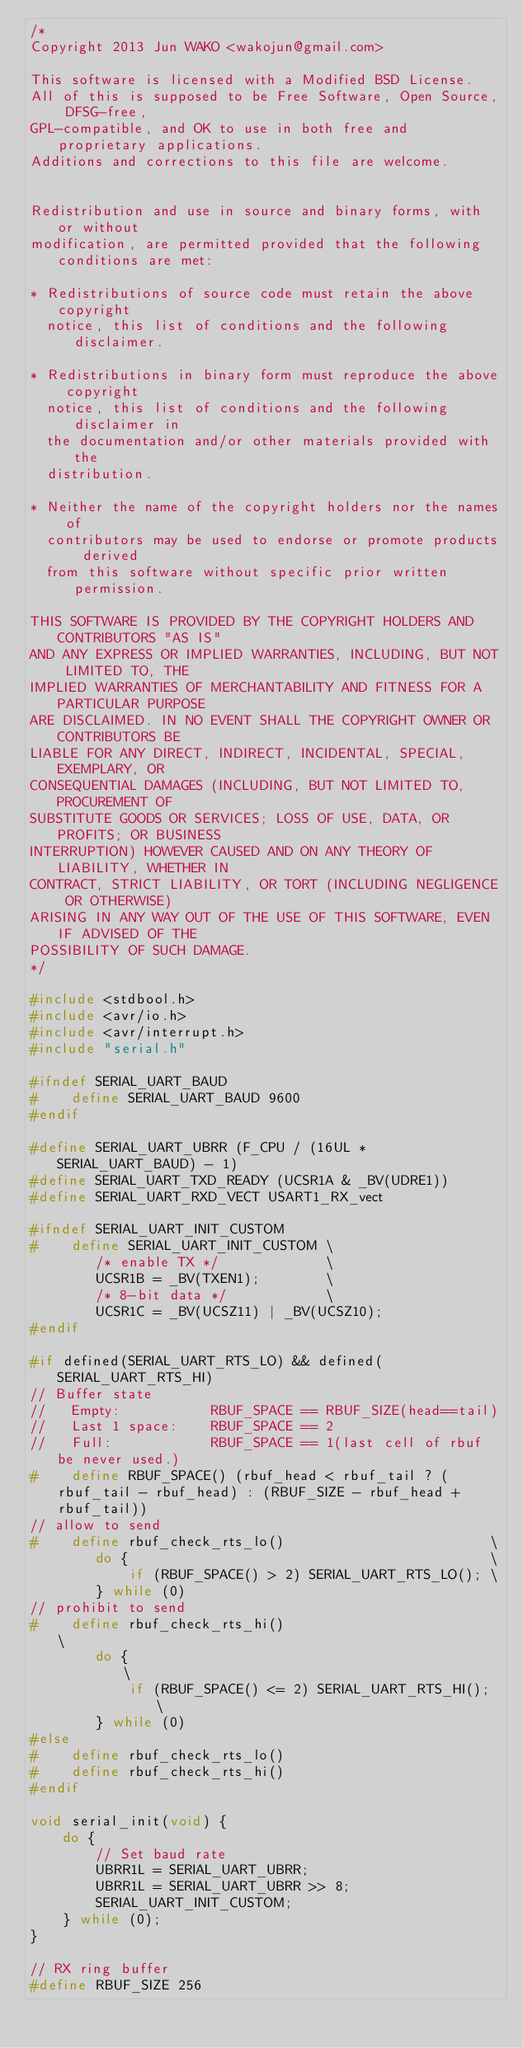<code> <loc_0><loc_0><loc_500><loc_500><_C_>/*
Copyright 2013 Jun WAKO <wakojun@gmail.com>

This software is licensed with a Modified BSD License.
All of this is supposed to be Free Software, Open Source, DFSG-free,
GPL-compatible, and OK to use in both free and proprietary applications.
Additions and corrections to this file are welcome.


Redistribution and use in source and binary forms, with or without
modification, are permitted provided that the following conditions are met:

* Redistributions of source code must retain the above copyright
  notice, this list of conditions and the following disclaimer.

* Redistributions in binary form must reproduce the above copyright
  notice, this list of conditions and the following disclaimer in
  the documentation and/or other materials provided with the
  distribution.

* Neither the name of the copyright holders nor the names of
  contributors may be used to endorse or promote products derived
  from this software without specific prior written permission.

THIS SOFTWARE IS PROVIDED BY THE COPYRIGHT HOLDERS AND CONTRIBUTORS "AS IS"
AND ANY EXPRESS OR IMPLIED WARRANTIES, INCLUDING, BUT NOT LIMITED TO, THE
IMPLIED WARRANTIES OF MERCHANTABILITY AND FITNESS FOR A PARTICULAR PURPOSE
ARE DISCLAIMED. IN NO EVENT SHALL THE COPYRIGHT OWNER OR CONTRIBUTORS BE
LIABLE FOR ANY DIRECT, INDIRECT, INCIDENTAL, SPECIAL, EXEMPLARY, OR
CONSEQUENTIAL DAMAGES (INCLUDING, BUT NOT LIMITED TO, PROCUREMENT OF
SUBSTITUTE GOODS OR SERVICES; LOSS OF USE, DATA, OR PROFITS; OR BUSINESS
INTERRUPTION) HOWEVER CAUSED AND ON ANY THEORY OF LIABILITY, WHETHER IN
CONTRACT, STRICT LIABILITY, OR TORT (INCLUDING NEGLIGENCE OR OTHERWISE)
ARISING IN ANY WAY OUT OF THE USE OF THIS SOFTWARE, EVEN IF ADVISED OF THE
POSSIBILITY OF SUCH DAMAGE.
*/

#include <stdbool.h>
#include <avr/io.h>
#include <avr/interrupt.h>
#include "serial.h"

#ifndef SERIAL_UART_BAUD
#    define SERIAL_UART_BAUD 9600
#endif

#define SERIAL_UART_UBRR (F_CPU / (16UL * SERIAL_UART_BAUD) - 1)
#define SERIAL_UART_TXD_READY (UCSR1A & _BV(UDRE1))
#define SERIAL_UART_RXD_VECT USART1_RX_vect

#ifndef SERIAL_UART_INIT_CUSTOM
#    define SERIAL_UART_INIT_CUSTOM \
        /* enable TX */             \
        UCSR1B = _BV(TXEN1);        \
        /* 8-bit data */            \
        UCSR1C = _BV(UCSZ11) | _BV(UCSZ10);
#endif

#if defined(SERIAL_UART_RTS_LO) && defined(SERIAL_UART_RTS_HI)
// Buffer state
//   Empty:           RBUF_SPACE == RBUF_SIZE(head==tail)
//   Last 1 space:    RBUF_SPACE == 2
//   Full:            RBUF_SPACE == 1(last cell of rbuf be never used.)
#    define RBUF_SPACE() (rbuf_head < rbuf_tail ? (rbuf_tail - rbuf_head) : (RBUF_SIZE - rbuf_head + rbuf_tail))
// allow to send
#    define rbuf_check_rts_lo()                         \
        do {                                            \
            if (RBUF_SPACE() > 2) SERIAL_UART_RTS_LO(); \
        } while (0)
// prohibit to send
#    define rbuf_check_rts_hi()                          \
        do {                                             \
            if (RBUF_SPACE() <= 2) SERIAL_UART_RTS_HI(); \
        } while (0)
#else
#    define rbuf_check_rts_lo()
#    define rbuf_check_rts_hi()
#endif

void serial_init(void) {
    do {
        // Set baud rate
        UBRR1L = SERIAL_UART_UBRR;
        UBRR1L = SERIAL_UART_UBRR >> 8;
        SERIAL_UART_INIT_CUSTOM;
    } while (0);
}

// RX ring buffer
#define RBUF_SIZE 256</code> 